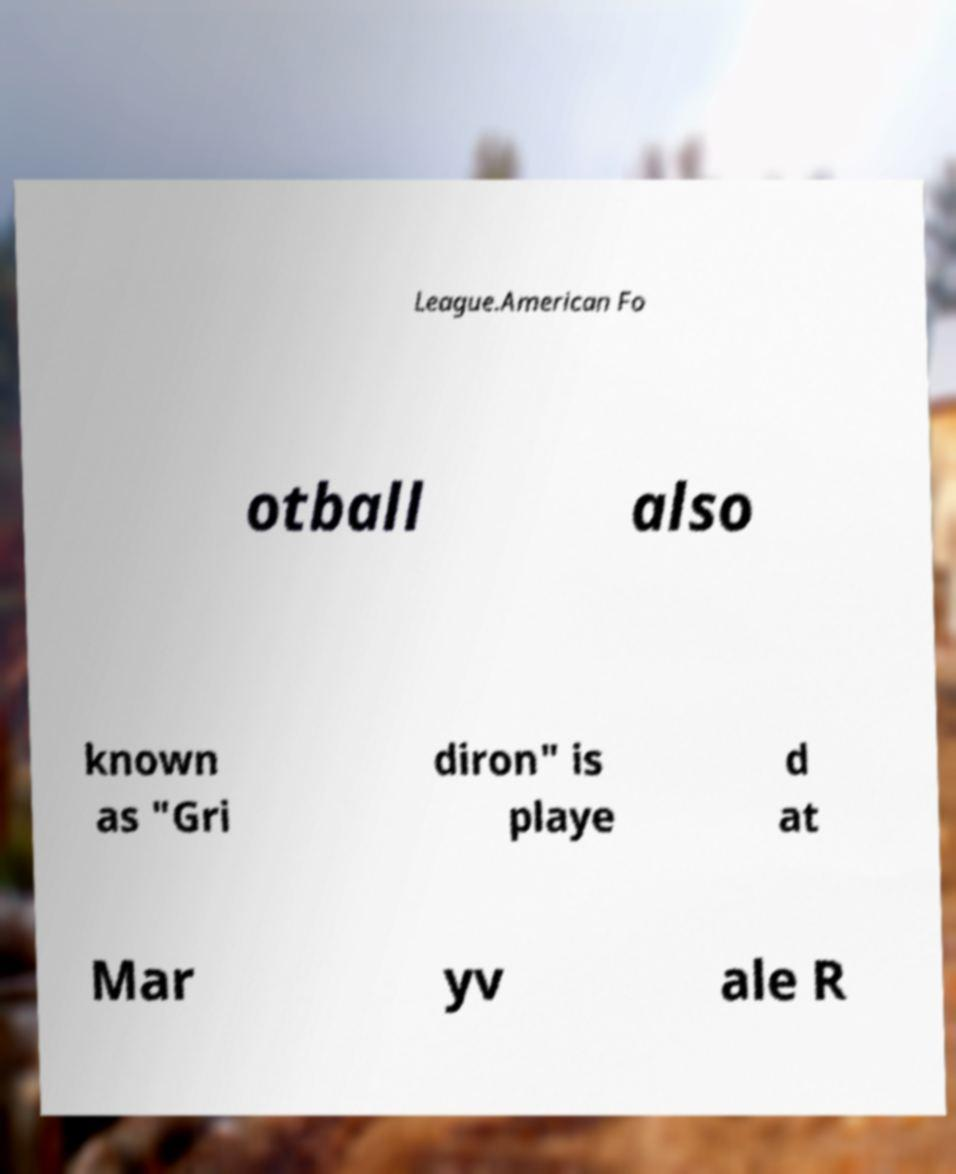There's text embedded in this image that I need extracted. Can you transcribe it verbatim? League.American Fo otball also known as "Gri diron" is playe d at Mar yv ale R 